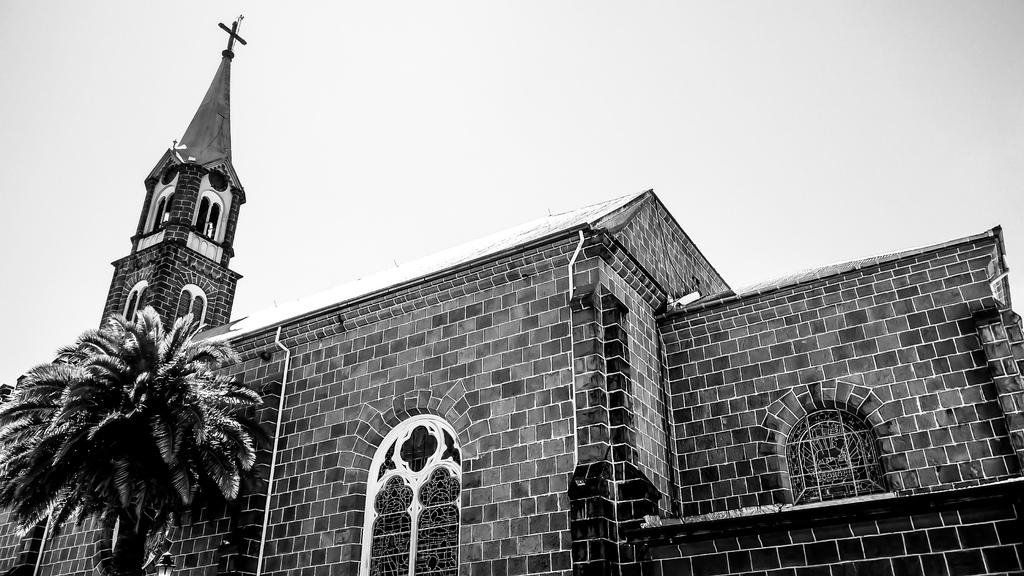What is the main structure in the image? There is a building in the image. What feature can be seen on the building? The building has windows. What type of natural element is present near the building? There is a tree beside the building. What symbol is visible at the top of the screen? There is a cross symbol at the top of the screen. What type of pollution can be seen coming from the building in the image? There is no indication of pollution in the image; the building appears to be a normal structure with windows and a tree nearby. 